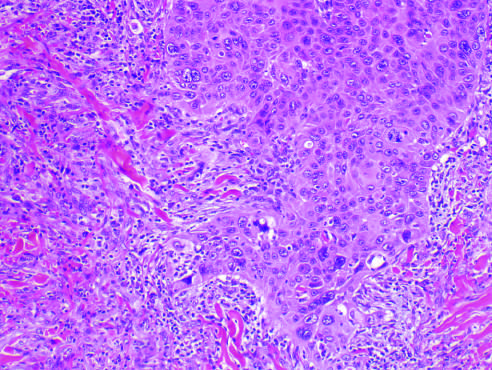did irregular projections of atypical squamous cells exhibit acantholysis?
Answer the question using a single word or phrase. Yes 